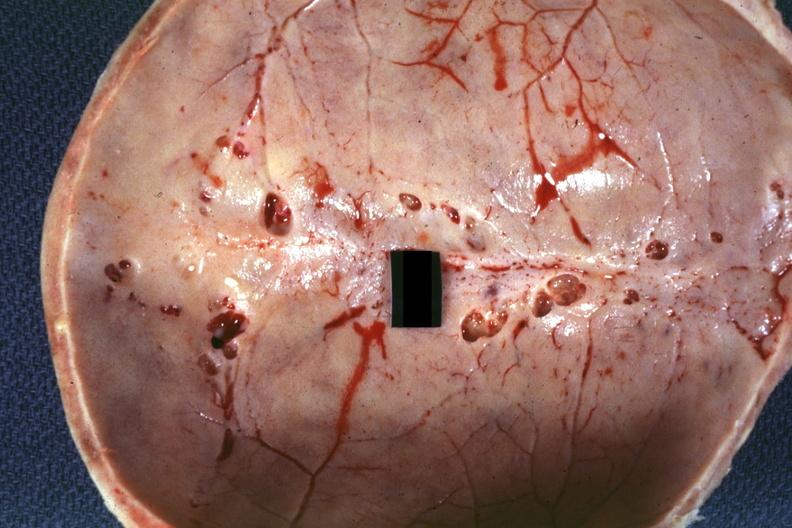s bone, calvarium present?
Answer the question using a single word or phrase. Yes 